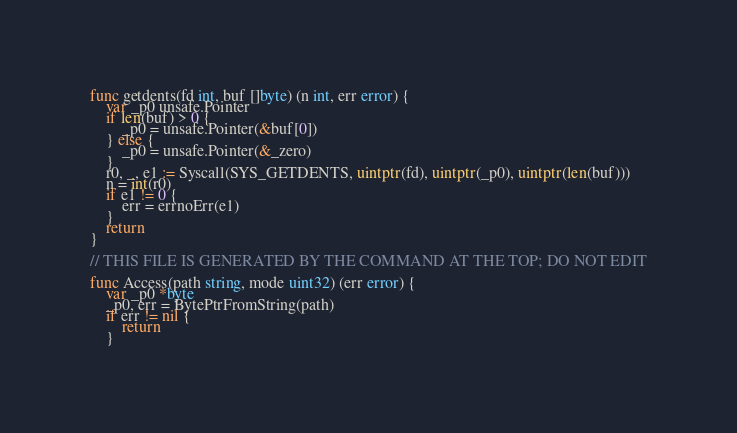Convert code to text. <code><loc_0><loc_0><loc_500><loc_500><_Go_>func getdents(fd int, buf []byte) (n int, err error) {
	var _p0 unsafe.Pointer
	if len(buf) > 0 {
		_p0 = unsafe.Pointer(&buf[0])
	} else {
		_p0 = unsafe.Pointer(&_zero)
	}
	r0, _, e1 := Syscall(SYS_GETDENTS, uintptr(fd), uintptr(_p0), uintptr(len(buf)))
	n = int(r0)
	if e1 != 0 {
		err = errnoErr(e1)
	}
	return
}

// THIS FILE IS GENERATED BY THE COMMAND AT THE TOP; DO NOT EDIT

func Access(path string, mode uint32) (err error) {
	var _p0 *byte
	_p0, err = BytePtrFromString(path)
	if err != nil {
		return
	}</code> 